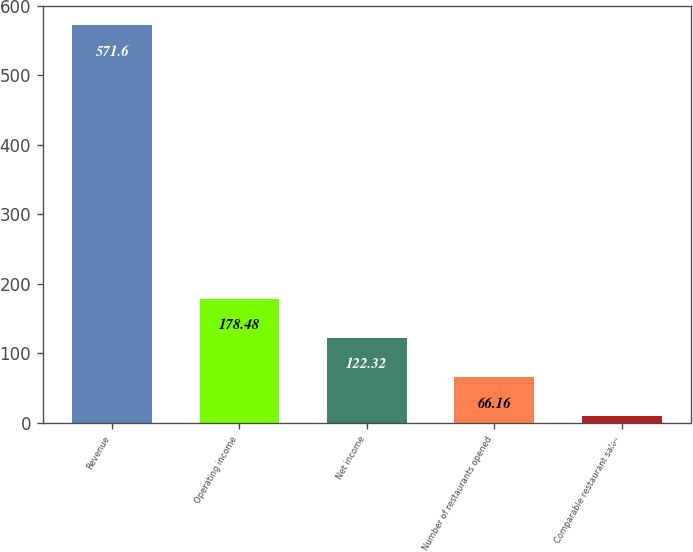<chart> <loc_0><loc_0><loc_500><loc_500><bar_chart><fcel>Revenue<fcel>Operating income<fcel>Net income<fcel>Number of restaurants opened<fcel>Comparable restaurant sales<nl><fcel>571.6<fcel>178.48<fcel>122.32<fcel>66.16<fcel>10<nl></chart> 